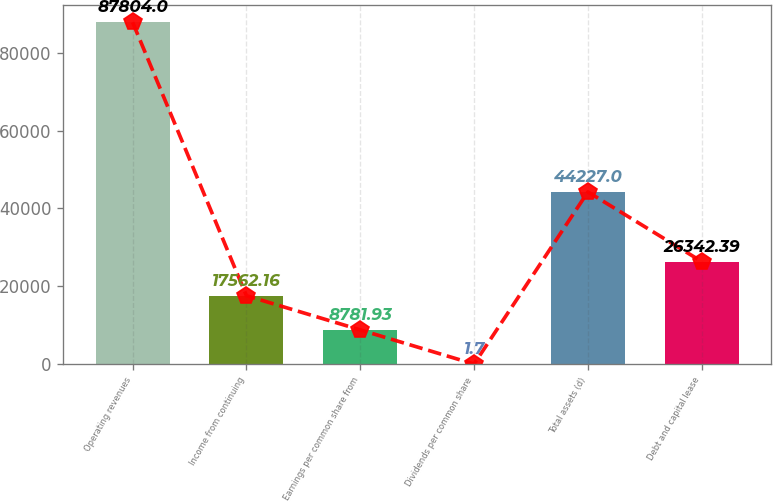Convert chart. <chart><loc_0><loc_0><loc_500><loc_500><bar_chart><fcel>Operating revenues<fcel>Income from continuing<fcel>Earnings per common share from<fcel>Dividends per common share<fcel>Total assets (d)<fcel>Debt and capital lease<nl><fcel>87804<fcel>17562.2<fcel>8781.93<fcel>1.7<fcel>44227<fcel>26342.4<nl></chart> 